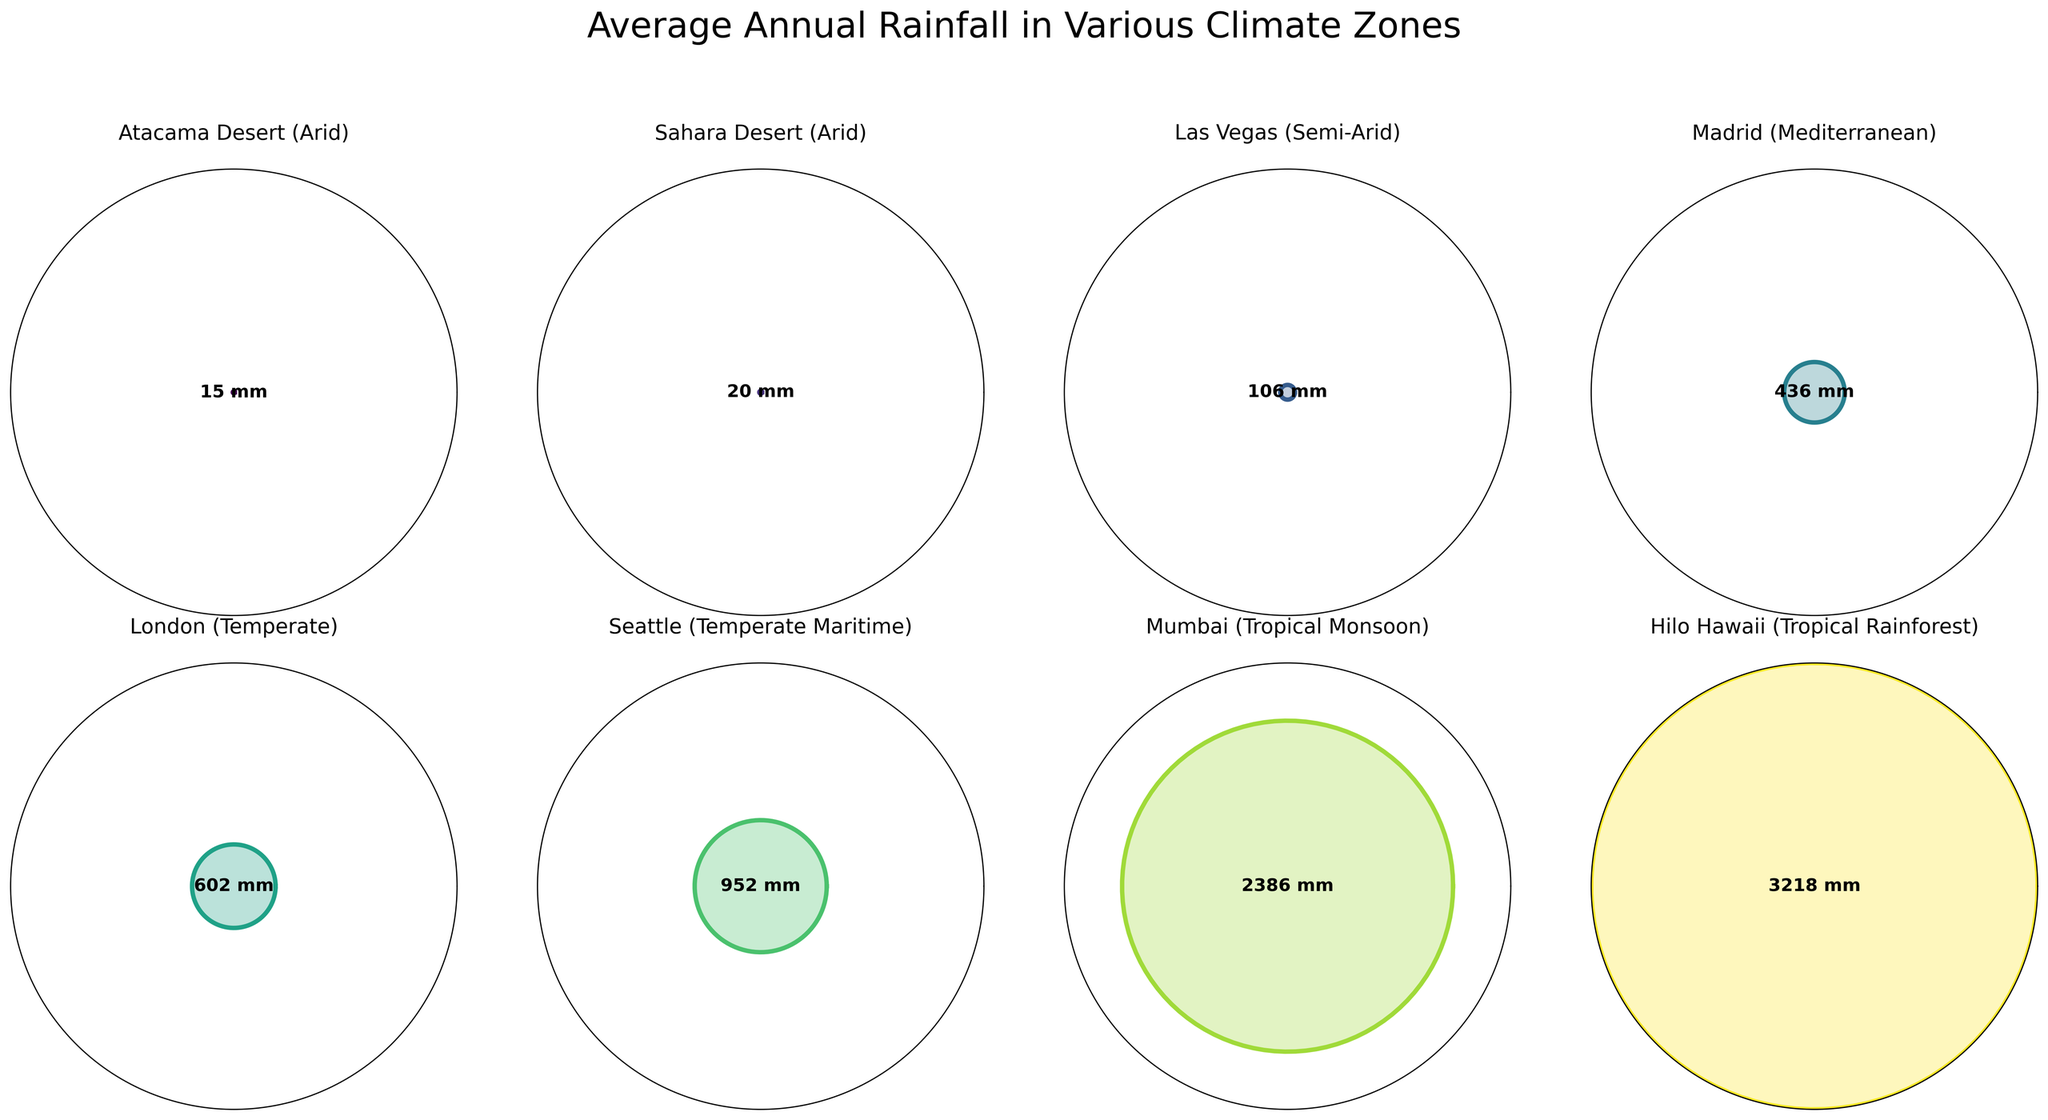What's the title of the figure? The title is prominently placed above the subplots and reads "Average Annual Rainfall in Various Climate Zones".
Answer: Average Annual Rainfall in Various Climate Zones How many climate zones are depicted in the figure? The figure contains one subplot for each climate zone. By counting the subplots, we see there are eight subplots in total.
Answer: 8 Which climate zone has the highest average annual rainfall? The plot for each climate zone shows the rainfall value in the center. The highest value is 3218 mm, corresponding to the "Hilo Hawaii (Tropical Rainforest)" zone.
Answer: Hilo Hawaii (Tropical Rainforest) What is the approximate range of average annual rainfall values shown in the figure? The smallest rainfall value is 15 mm (Atacama Desert), and the largest is 3218 mm (Hilo Hawaii). Subtract the smallest from the largest to find the range: 3218 mm - 15 mm.
Answer: 3203 mm Which two climate zones have the closest average annual rainfall values? Comparing the rainfall values closely, "Atacama Desert (15 mm)" and "Sahara Desert (20 mm)" are the closest, having a difference of only 5 mm.
Answer: Atacama Desert and Sahara Desert Arrange the climate zones in descending order of average annual rainfall. Listing the values: Hilo Hawaii (3218 mm), Mumbai (2386 mm), Seattle (952 mm), London (602 mm), Madrid (436 mm), Las Vegas (106 mm), Sahara Desert (20 mm), and Atacama Desert (15 mm).
Answer: Hilo Hawaii, Mumbai, Seattle, London, Madrid, Las Vegas, Sahara Desert, Atacama Desert Which climate zone falls under the "Tropical Monsoon" category and what is its average annual rainfall? Checking the subplots for "Tropical Monsoon," "Mumbai" is labeled accordingly, with an average annual rainfall of 2386 mm prominently shown.
Answer: Mumbai, 2386 mm How is the correlation between the climate zone type and average annual rainfall visually represented? Each subplot shows the climate type and the corresponding rainfall in mm; the zones range from arid to tropical rainforest, each visually indicating increasing rainfall by the filled polar plot area.
Answer: Increasing filled area with wetter climates What is the average annual rainfall of "Madrid," and which climate category does it belong to? The subplot labeled "Madrid" shows an average annual rainfall of 436 mm and is categorized under "Mediterranean."
Answer: 436 mm, Mediterranean Compare the average annual rainfall between "Las Vegas (Semi-Arid)" and "London (Temperate)." Which one receives more, and by how much? Las Vegas has 106 mm, and London has 602 mm of average annual rainfall. London receives more rainfall: 602 mm - 106 mm = 496 mm.
Answer: London, by 496 mm 